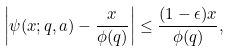Convert formula to latex. <formula><loc_0><loc_0><loc_500><loc_500>\left | \psi ( x ; q , a ) - \frac { x } { \phi ( q ) } \right | \leq \frac { ( 1 - \epsilon ) x } { \phi ( q ) } ,</formula> 